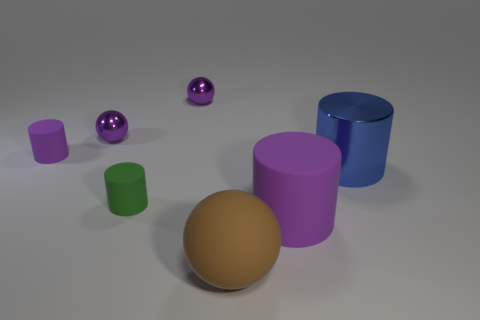How many rubber cylinders are both to the right of the big matte sphere and behind the big blue object?
Give a very brief answer. 0. There is a blue metallic cylinder; are there any metallic things on the left side of it?
Provide a succinct answer. Yes. Does the purple matte thing in front of the green matte cylinder have the same shape as the shiny object to the right of the big brown ball?
Provide a short and direct response. Yes. What number of objects are either big brown balls or cylinders that are behind the big metallic cylinder?
Offer a very short reply. 2. How many other objects are the same shape as the big blue object?
Keep it short and to the point. 3. Are the tiny green object that is in front of the blue cylinder and the big purple object made of the same material?
Your response must be concise. Yes. What number of objects are big yellow cylinders or small metallic spheres?
Provide a short and direct response. 2. There is a blue object that is the same shape as the large purple thing; what is its size?
Your response must be concise. Large. What size is the blue metal cylinder?
Give a very brief answer. Large. Is the number of tiny purple metallic things on the left side of the large brown matte ball greater than the number of big green matte cubes?
Offer a terse response. Yes. 